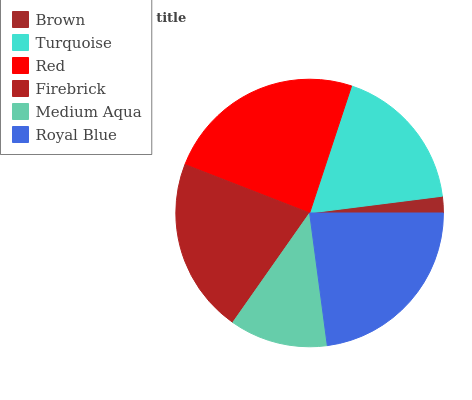Is Brown the minimum?
Answer yes or no. Yes. Is Red the maximum?
Answer yes or no. Yes. Is Turquoise the minimum?
Answer yes or no. No. Is Turquoise the maximum?
Answer yes or no. No. Is Turquoise greater than Brown?
Answer yes or no. Yes. Is Brown less than Turquoise?
Answer yes or no. Yes. Is Brown greater than Turquoise?
Answer yes or no. No. Is Turquoise less than Brown?
Answer yes or no. No. Is Firebrick the high median?
Answer yes or no. Yes. Is Turquoise the low median?
Answer yes or no. Yes. Is Turquoise the high median?
Answer yes or no. No. Is Medium Aqua the low median?
Answer yes or no. No. 